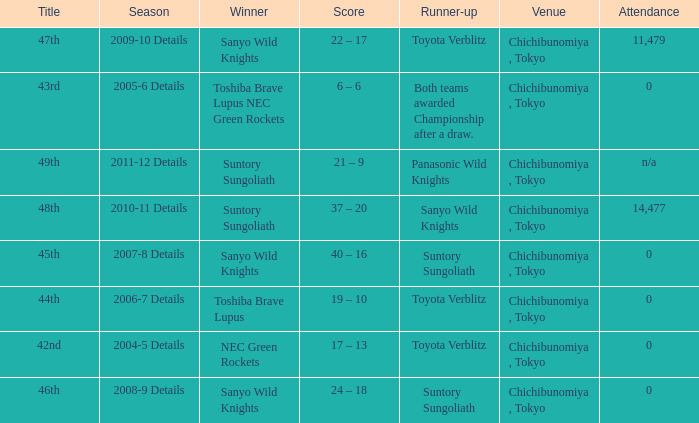What is the Score when the winner was suntory sungoliath, and the number attendance was n/a? 21 – 9. Can you give me this table as a dict? {'header': ['Title', 'Season', 'Winner', 'Score', 'Runner-up', 'Venue', 'Attendance'], 'rows': [['47th', '2009-10 Details', 'Sanyo Wild Knights', '22 – 17', 'Toyota Verblitz', 'Chichibunomiya , Tokyo', '11,479'], ['43rd', '2005-6 Details', 'Toshiba Brave Lupus NEC Green Rockets', '6 – 6', 'Both teams awarded Championship after a draw.', 'Chichibunomiya , Tokyo', '0'], ['49th', '2011-12 Details', 'Suntory Sungoliath', '21 – 9', 'Panasonic Wild Knights', 'Chichibunomiya , Tokyo', 'n/a'], ['48th', '2010-11 Details', 'Suntory Sungoliath', '37 – 20', 'Sanyo Wild Knights', 'Chichibunomiya , Tokyo', '14,477'], ['45th', '2007-8 Details', 'Sanyo Wild Knights', '40 – 16', 'Suntory Sungoliath', 'Chichibunomiya , Tokyo', '0'], ['44th', '2006-7 Details', 'Toshiba Brave Lupus', '19 – 10', 'Toyota Verblitz', 'Chichibunomiya , Tokyo', '0'], ['42nd', '2004-5 Details', 'NEC Green Rockets', '17 – 13', 'Toyota Verblitz', 'Chichibunomiya , Tokyo', '0'], ['46th', '2008-9 Details', 'Sanyo Wild Knights', '24 – 18', 'Suntory Sungoliath', 'Chichibunomiya , Tokyo', '0']]} 